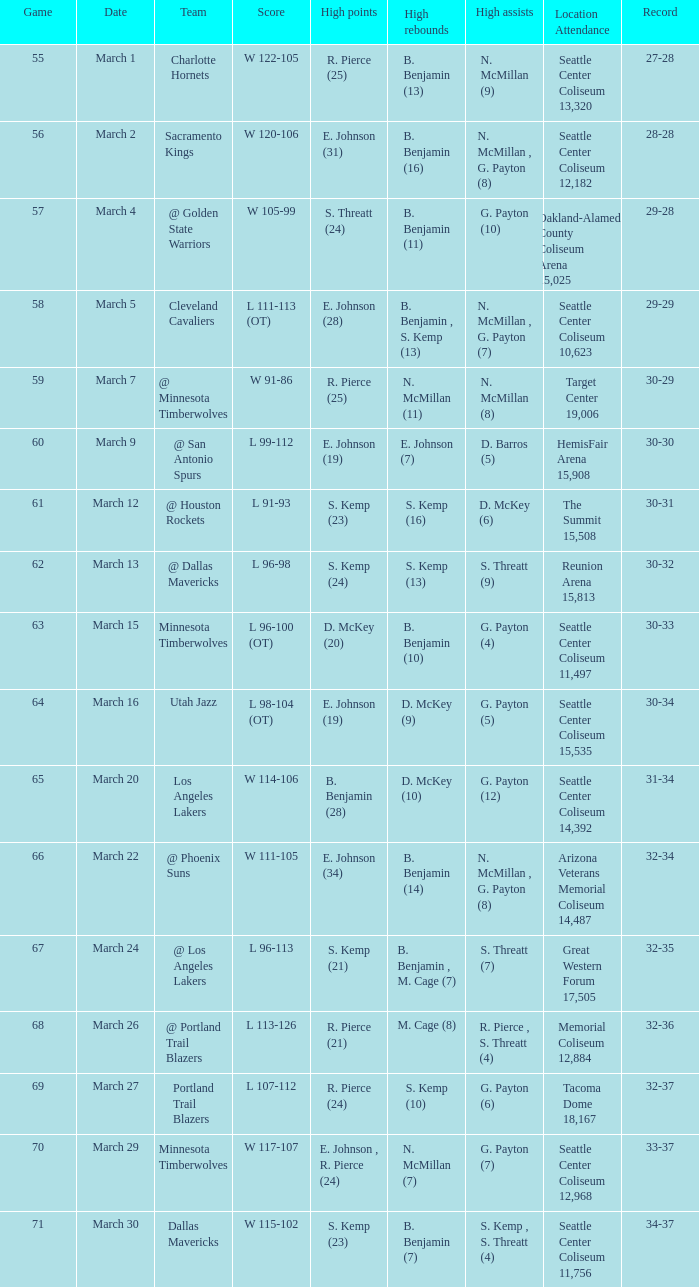WhichScore has a Location Attendance of seattle center coliseum 11,497? L 96-100 (OT). 